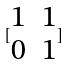Convert formula to latex. <formula><loc_0><loc_0><loc_500><loc_500>[ \begin{matrix} 1 & 1 \\ 0 & 1 \end{matrix} ]</formula> 